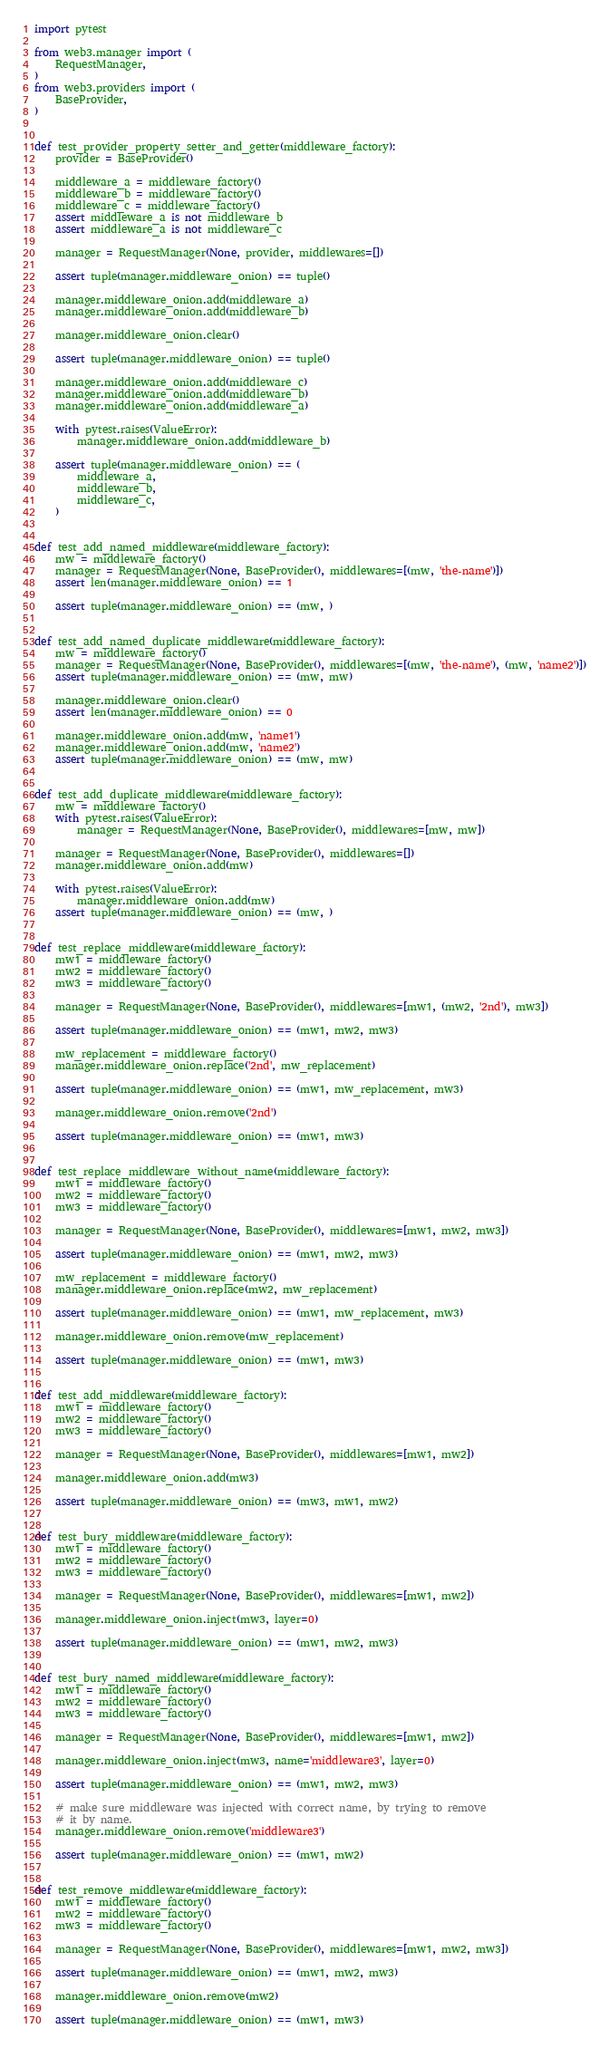Convert code to text. <code><loc_0><loc_0><loc_500><loc_500><_Python_>import pytest

from web3.manager import (
    RequestManager,
)
from web3.providers import (
    BaseProvider,
)


def test_provider_property_setter_and_getter(middleware_factory):
    provider = BaseProvider()

    middleware_a = middleware_factory()
    middleware_b = middleware_factory()
    middleware_c = middleware_factory()
    assert middleware_a is not middleware_b
    assert middleware_a is not middleware_c

    manager = RequestManager(None, provider, middlewares=[])

    assert tuple(manager.middleware_onion) == tuple()

    manager.middleware_onion.add(middleware_a)
    manager.middleware_onion.add(middleware_b)

    manager.middleware_onion.clear()

    assert tuple(manager.middleware_onion) == tuple()

    manager.middleware_onion.add(middleware_c)
    manager.middleware_onion.add(middleware_b)
    manager.middleware_onion.add(middleware_a)

    with pytest.raises(ValueError):
        manager.middleware_onion.add(middleware_b)

    assert tuple(manager.middleware_onion) == (
        middleware_a,
        middleware_b,
        middleware_c,
    )


def test_add_named_middleware(middleware_factory):
    mw = middleware_factory()
    manager = RequestManager(None, BaseProvider(), middlewares=[(mw, 'the-name')])
    assert len(manager.middleware_onion) == 1

    assert tuple(manager.middleware_onion) == (mw, )


def test_add_named_duplicate_middleware(middleware_factory):
    mw = middleware_factory()
    manager = RequestManager(None, BaseProvider(), middlewares=[(mw, 'the-name'), (mw, 'name2')])
    assert tuple(manager.middleware_onion) == (mw, mw)

    manager.middleware_onion.clear()
    assert len(manager.middleware_onion) == 0

    manager.middleware_onion.add(mw, 'name1')
    manager.middleware_onion.add(mw, 'name2')
    assert tuple(manager.middleware_onion) == (mw, mw)


def test_add_duplicate_middleware(middleware_factory):
    mw = middleware_factory()
    with pytest.raises(ValueError):
        manager = RequestManager(None, BaseProvider(), middlewares=[mw, mw])

    manager = RequestManager(None, BaseProvider(), middlewares=[])
    manager.middleware_onion.add(mw)

    with pytest.raises(ValueError):
        manager.middleware_onion.add(mw)
    assert tuple(manager.middleware_onion) == (mw, )


def test_replace_middleware(middleware_factory):
    mw1 = middleware_factory()
    mw2 = middleware_factory()
    mw3 = middleware_factory()

    manager = RequestManager(None, BaseProvider(), middlewares=[mw1, (mw2, '2nd'), mw3])

    assert tuple(manager.middleware_onion) == (mw1, mw2, mw3)

    mw_replacement = middleware_factory()
    manager.middleware_onion.replace('2nd', mw_replacement)

    assert tuple(manager.middleware_onion) == (mw1, mw_replacement, mw3)

    manager.middleware_onion.remove('2nd')

    assert tuple(manager.middleware_onion) == (mw1, mw3)


def test_replace_middleware_without_name(middleware_factory):
    mw1 = middleware_factory()
    mw2 = middleware_factory()
    mw3 = middleware_factory()

    manager = RequestManager(None, BaseProvider(), middlewares=[mw1, mw2, mw3])

    assert tuple(manager.middleware_onion) == (mw1, mw2, mw3)

    mw_replacement = middleware_factory()
    manager.middleware_onion.replace(mw2, mw_replacement)

    assert tuple(manager.middleware_onion) == (mw1, mw_replacement, mw3)

    manager.middleware_onion.remove(mw_replacement)

    assert tuple(manager.middleware_onion) == (mw1, mw3)


def test_add_middleware(middleware_factory):
    mw1 = middleware_factory()
    mw2 = middleware_factory()
    mw3 = middleware_factory()

    manager = RequestManager(None, BaseProvider(), middlewares=[mw1, mw2])

    manager.middleware_onion.add(mw3)

    assert tuple(manager.middleware_onion) == (mw3, mw1, mw2)


def test_bury_middleware(middleware_factory):
    mw1 = middleware_factory()
    mw2 = middleware_factory()
    mw3 = middleware_factory()

    manager = RequestManager(None, BaseProvider(), middlewares=[mw1, mw2])

    manager.middleware_onion.inject(mw3, layer=0)

    assert tuple(manager.middleware_onion) == (mw1, mw2, mw3)


def test_bury_named_middleware(middleware_factory):
    mw1 = middleware_factory()
    mw2 = middleware_factory()
    mw3 = middleware_factory()

    manager = RequestManager(None, BaseProvider(), middlewares=[mw1, mw2])

    manager.middleware_onion.inject(mw3, name='middleware3', layer=0)

    assert tuple(manager.middleware_onion) == (mw1, mw2, mw3)

    # make sure middleware was injected with correct name, by trying to remove
    # it by name.
    manager.middleware_onion.remove('middleware3')

    assert tuple(manager.middleware_onion) == (mw1, mw2)


def test_remove_middleware(middleware_factory):
    mw1 = middleware_factory()
    mw2 = middleware_factory()
    mw3 = middleware_factory()

    manager = RequestManager(None, BaseProvider(), middlewares=[mw1, mw2, mw3])

    assert tuple(manager.middleware_onion) == (mw1, mw2, mw3)

    manager.middleware_onion.remove(mw2)

    assert tuple(manager.middleware_onion) == (mw1, mw3)
</code> 